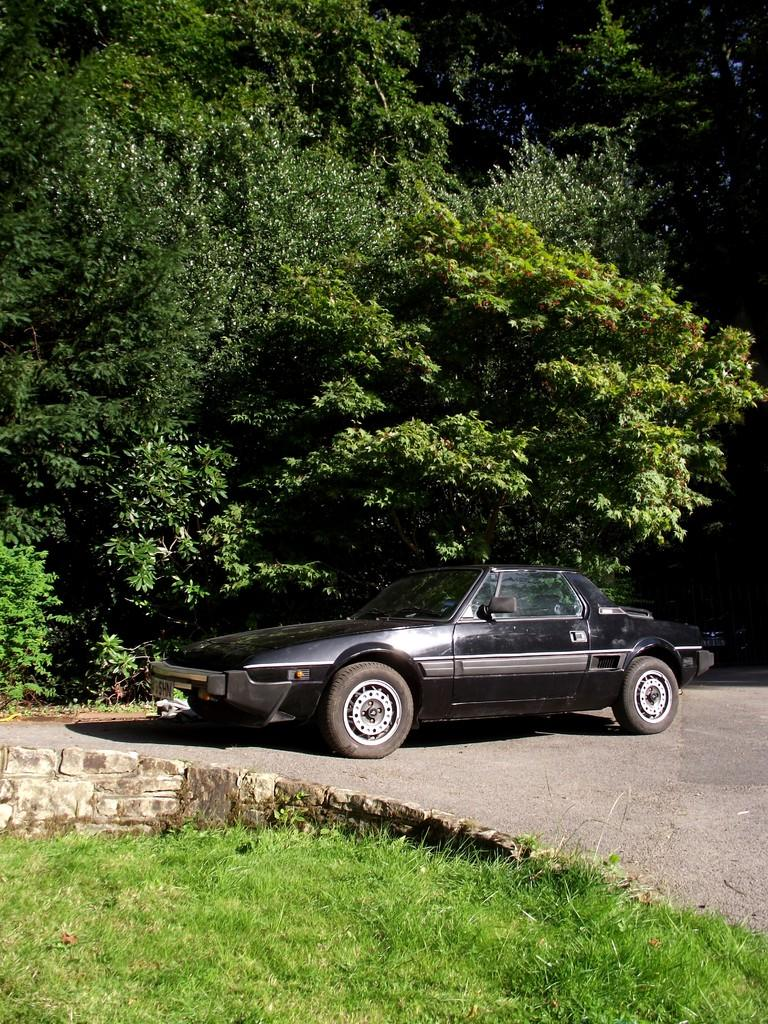What is the main subject of the image? There is a vehicle in the image. What color is the vehicle? The vehicle is black in color. What can be seen in the background of the image? There are trees in the background of the image. What is the color of the trees? The trees are green in color. What type of pet can be seen playing with a crayon in the image? There is no pet or crayon present in the image; it features a black vehicle and green trees in the background. Is the band performing in the image? There is no band or performance present in the image. 